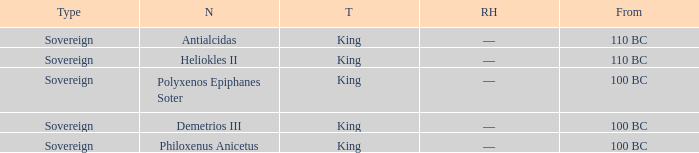When did Philoxenus Anicetus begin to hold power? 100 BC. 